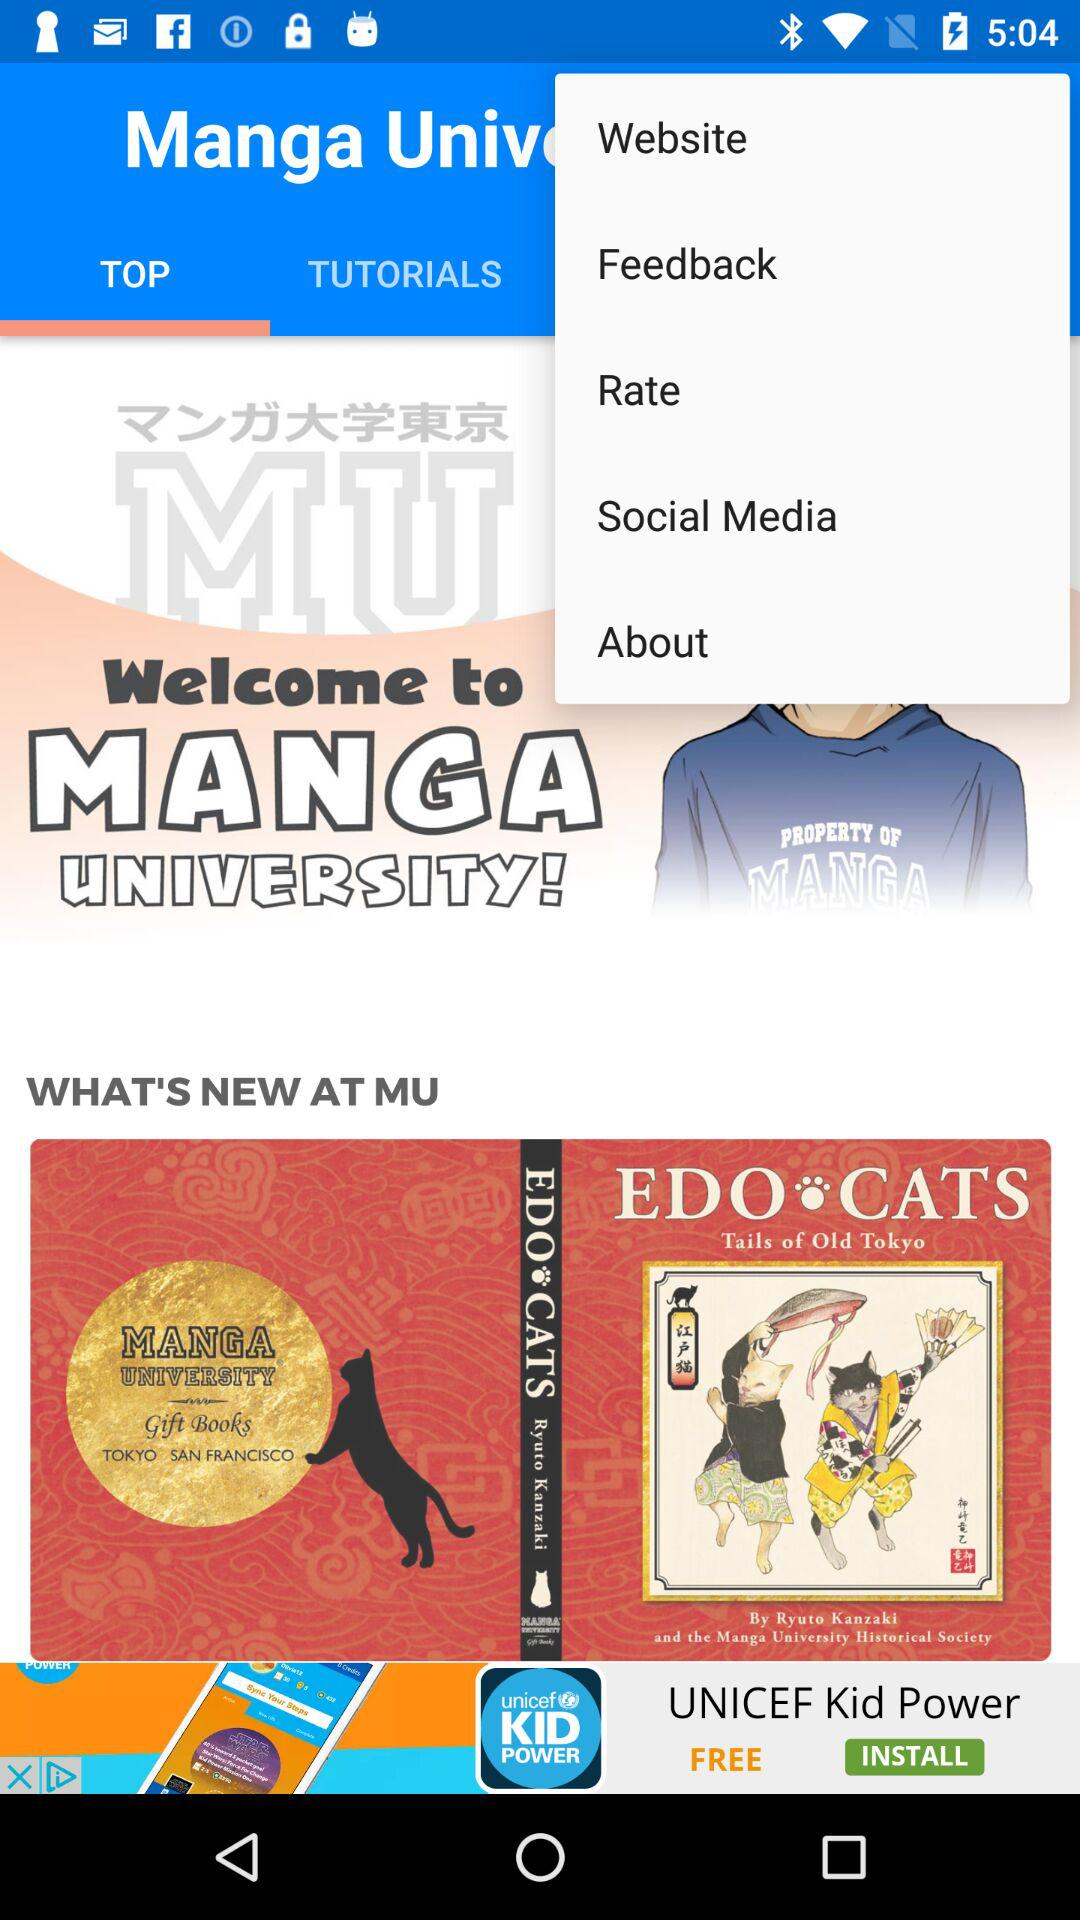Which is the selected tab? The selected tab is "TOP". 